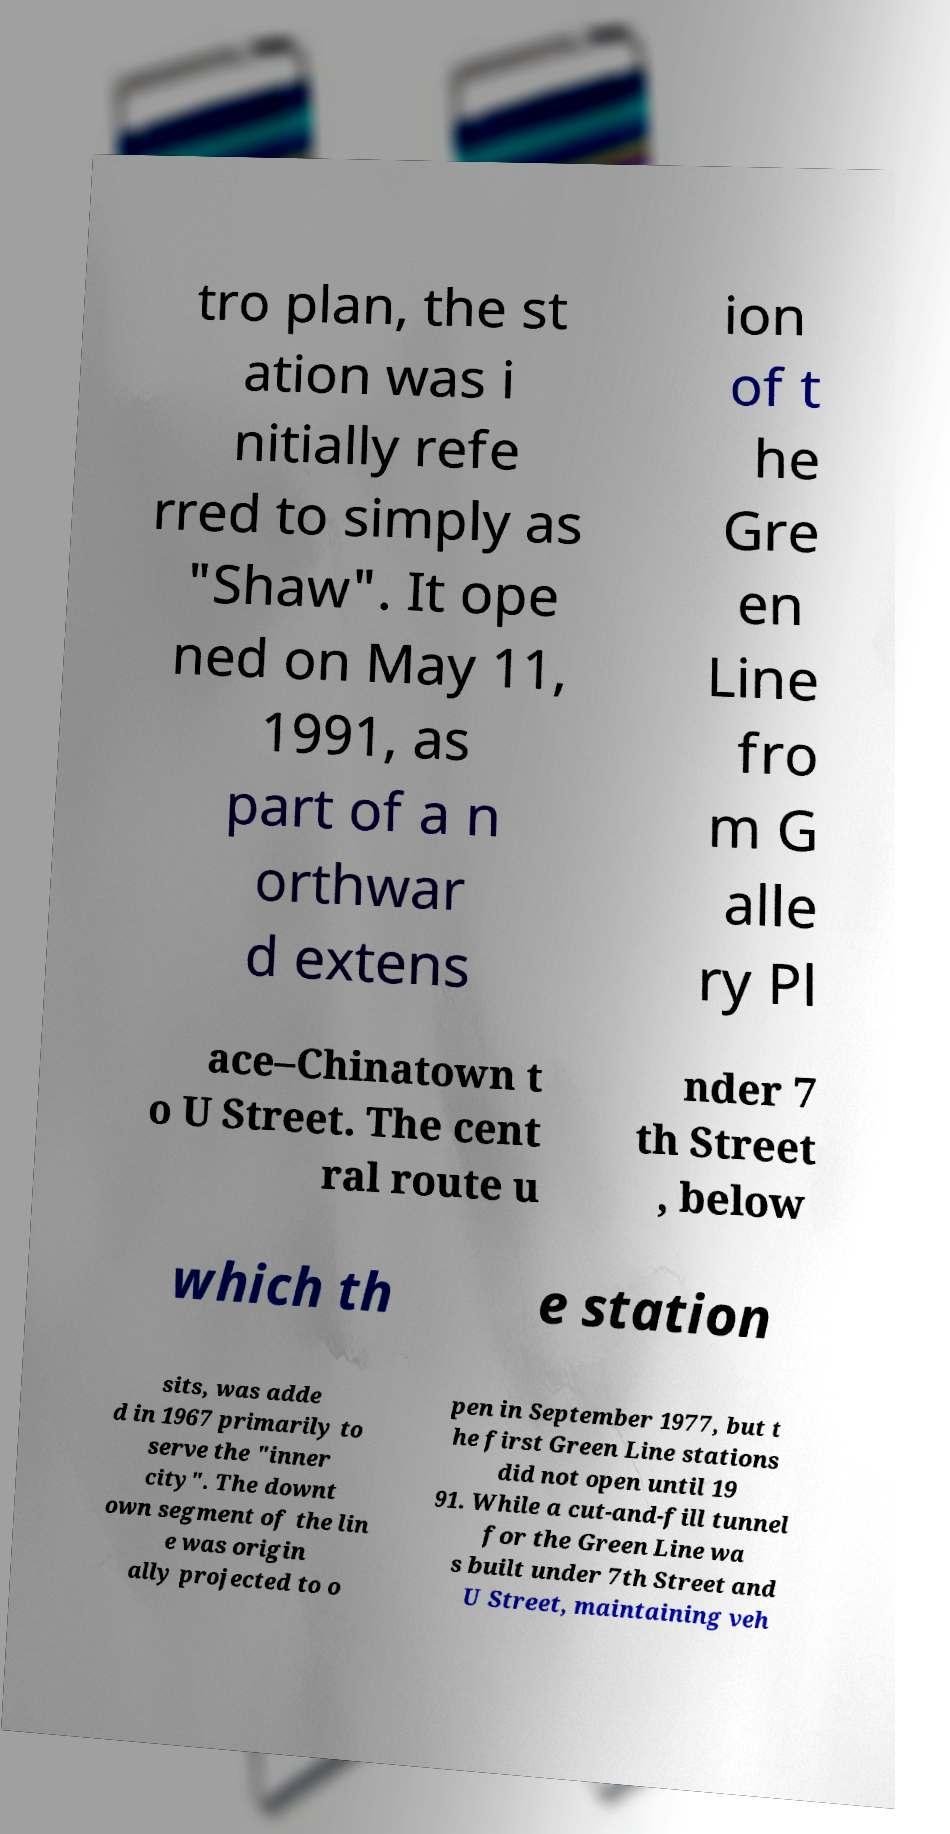Could you assist in decoding the text presented in this image and type it out clearly? tro plan, the st ation was i nitially refe rred to simply as "Shaw". It ope ned on May 11, 1991, as part of a n orthwar d extens ion of t he Gre en Line fro m G alle ry Pl ace–Chinatown t o U Street. The cent ral route u nder 7 th Street , below which th e station sits, was adde d in 1967 primarily to serve the "inner city". The downt own segment of the lin e was origin ally projected to o pen in September 1977, but t he first Green Line stations did not open until 19 91. While a cut-and-fill tunnel for the Green Line wa s built under 7th Street and U Street, maintaining veh 